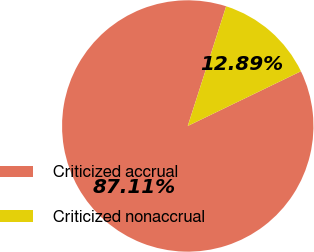<chart> <loc_0><loc_0><loc_500><loc_500><pie_chart><fcel>Criticized accrual<fcel>Criticized nonaccrual<nl><fcel>87.11%<fcel>12.89%<nl></chart> 